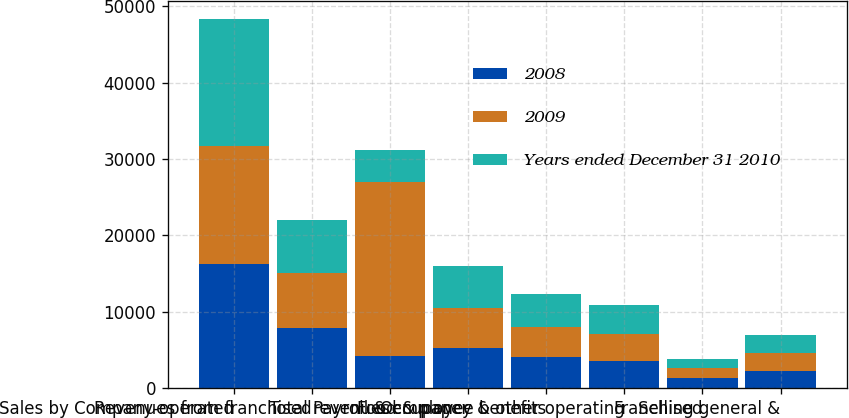Convert chart to OTSL. <chart><loc_0><loc_0><loc_500><loc_500><stacked_bar_chart><ecel><fcel>Sales by Company-operated<fcel>Revenues from franchised<fcel>Total revenues<fcel>Food & paper<fcel>Payroll & employee benefits<fcel>Occupancy & other operating<fcel>Franchised<fcel>Selling general &<nl><fcel>2008<fcel>16233.3<fcel>7841.3<fcel>4210.75<fcel>5300.1<fcel>4121.4<fcel>3638<fcel>1377.8<fcel>2333.3<nl><fcel>2009<fcel>15458.5<fcel>7286.2<fcel>22744.7<fcel>5178<fcel>3965.6<fcel>3507.6<fcel>1301.7<fcel>2234.2<nl><fcel>Years ended December 31 2010<fcel>16560.9<fcel>6961.5<fcel>4210.75<fcel>5586.1<fcel>4300.1<fcel>3766.7<fcel>1230.3<fcel>2355.5<nl></chart> 